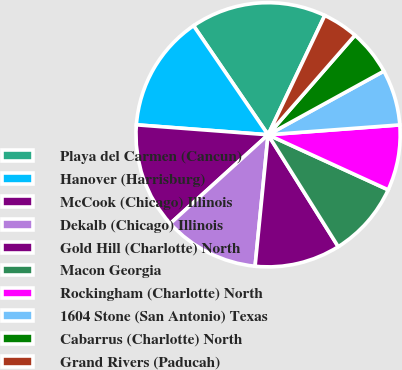Convert chart. <chart><loc_0><loc_0><loc_500><loc_500><pie_chart><fcel>Playa del Carmen (Cancun)<fcel>Hanover (Harrisburg)<fcel>McCook (Chicago) Illinois<fcel>Dekalb (Chicago) Illinois<fcel>Gold Hill (Charlotte) North<fcel>Macon Georgia<fcel>Rockingham (Charlotte) North<fcel>1604 Stone (San Antonio) Texas<fcel>Cabarrus (Charlotte) North<fcel>Grand Rivers (Paducah)<nl><fcel>16.6%<fcel>14.26%<fcel>12.93%<fcel>11.7%<fcel>10.48%<fcel>9.25%<fcel>8.03%<fcel>6.81%<fcel>5.58%<fcel>4.36%<nl></chart> 